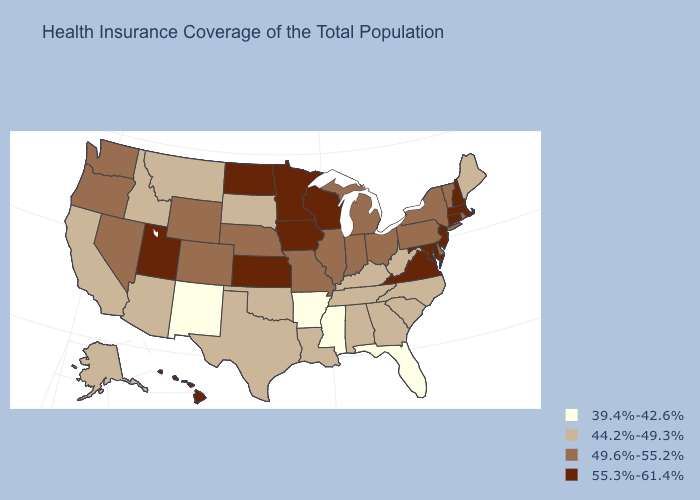Does New Mexico have the same value as Mississippi?
Be succinct. Yes. Is the legend a continuous bar?
Keep it brief. No. Does the first symbol in the legend represent the smallest category?
Quick response, please. Yes. Among the states that border California , does Nevada have the lowest value?
Be succinct. No. Among the states that border Delaware , does Maryland have the highest value?
Short answer required. Yes. What is the value of Maine?
Write a very short answer. 44.2%-49.3%. What is the highest value in states that border Texas?
Write a very short answer. 44.2%-49.3%. Which states have the lowest value in the USA?
Write a very short answer. Arkansas, Florida, Mississippi, New Mexico. What is the lowest value in the USA?
Give a very brief answer. 39.4%-42.6%. What is the highest value in the MidWest ?
Keep it brief. 55.3%-61.4%. Among the states that border Kansas , does Oklahoma have the highest value?
Answer briefly. No. What is the value of Arkansas?
Keep it brief. 39.4%-42.6%. How many symbols are there in the legend?
Quick response, please. 4. Name the states that have a value in the range 39.4%-42.6%?
Give a very brief answer. Arkansas, Florida, Mississippi, New Mexico. Which states have the highest value in the USA?
Write a very short answer. Connecticut, Hawaii, Iowa, Kansas, Maryland, Massachusetts, Minnesota, New Hampshire, New Jersey, North Dakota, Utah, Virginia, Wisconsin. 